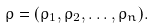Convert formula to latex. <formula><loc_0><loc_0><loc_500><loc_500>\varrho = ( \rho _ { 1 } , \rho _ { 2 } , \dots , \rho _ { n } ) .</formula> 